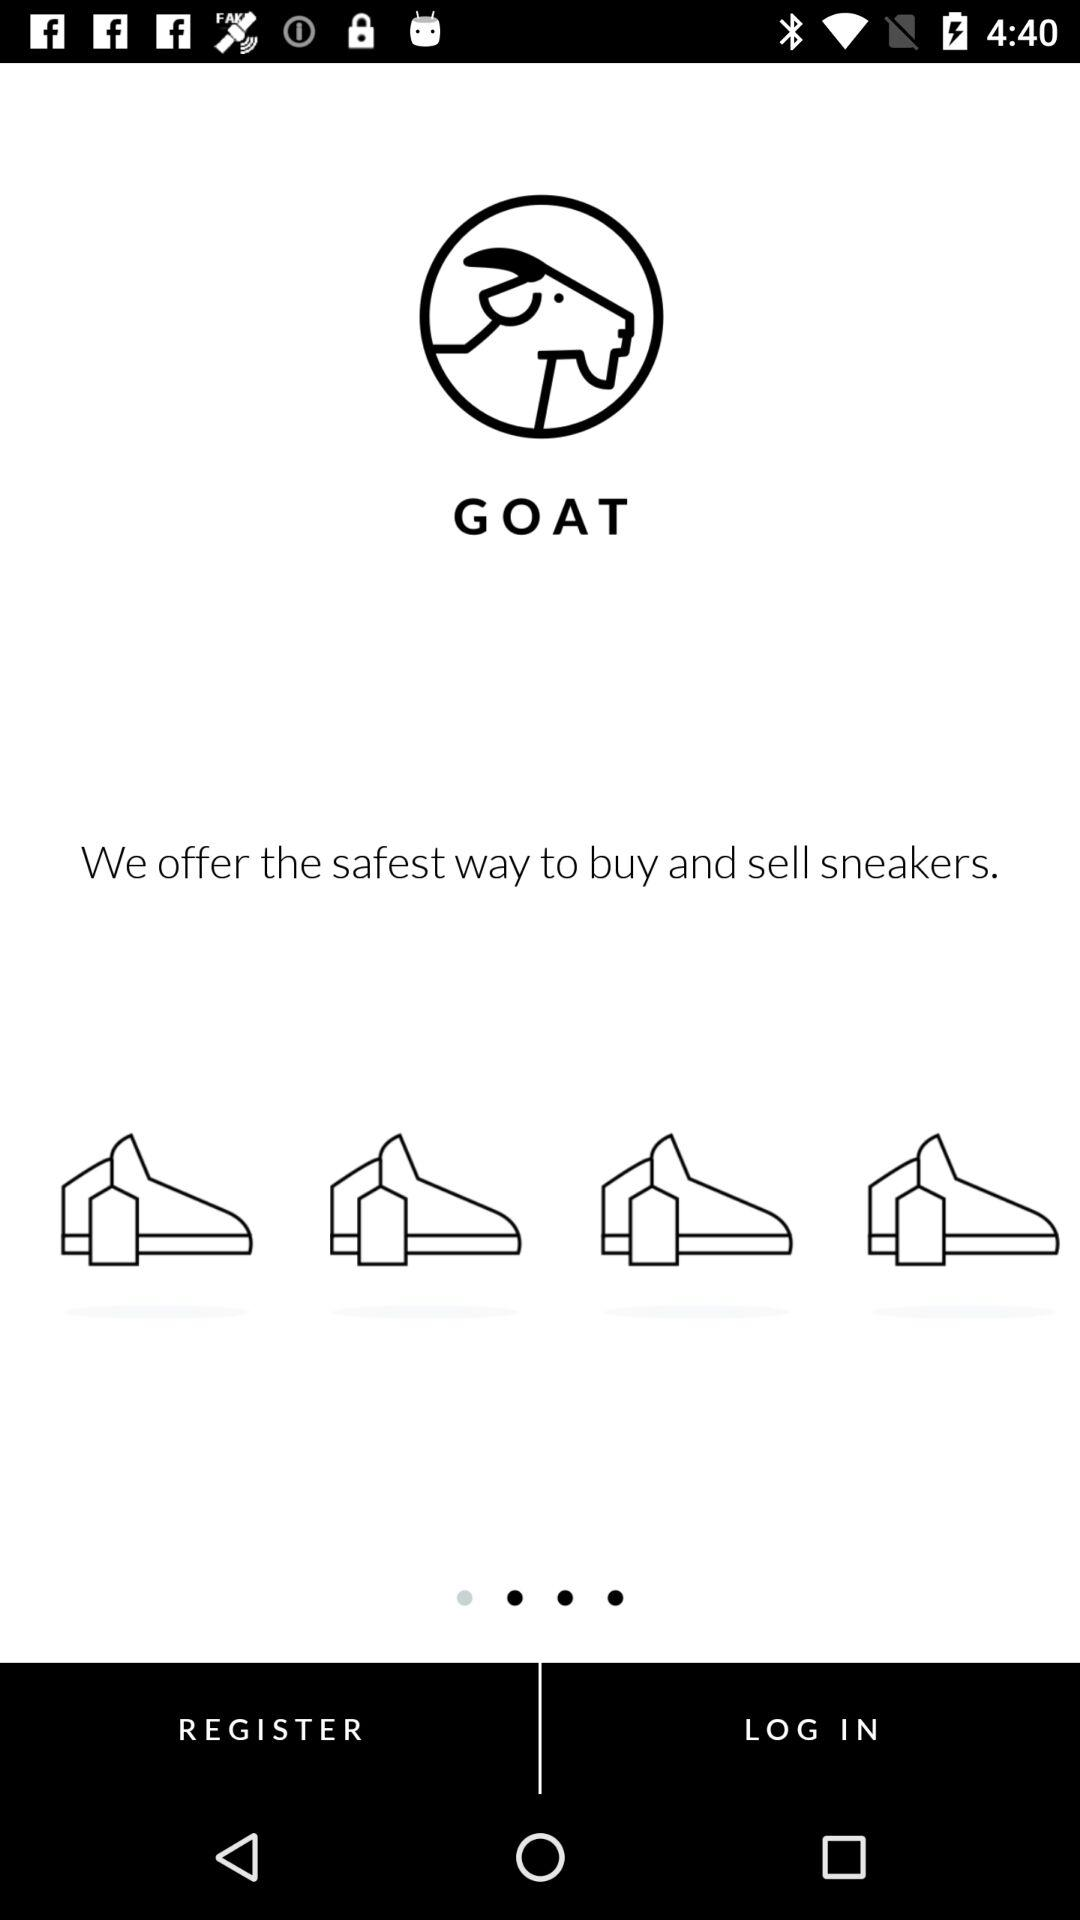What is the application name? The application name is "GOAT". 